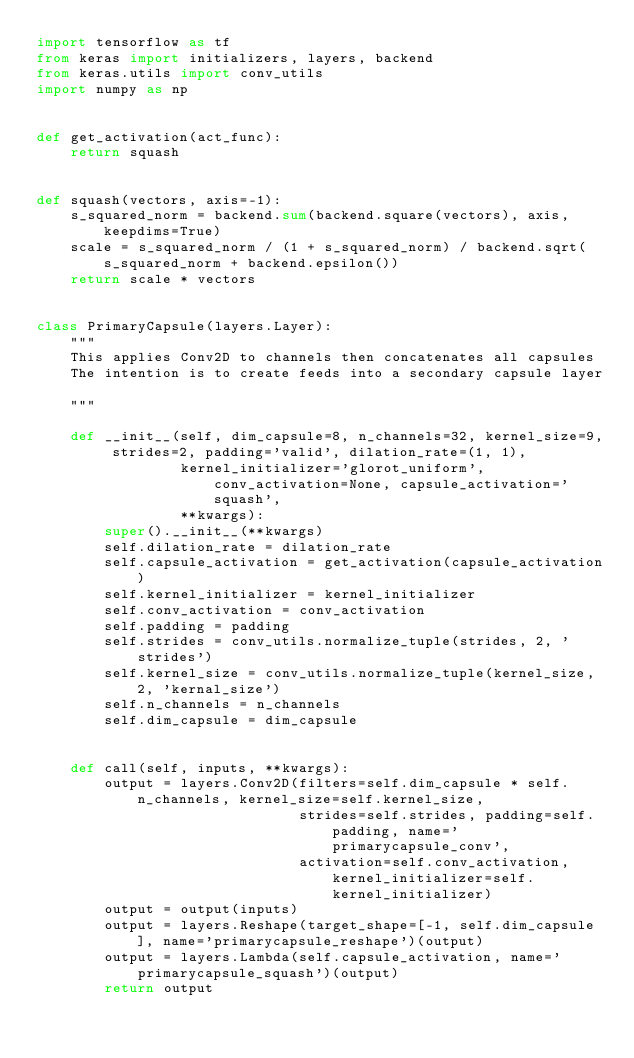Convert code to text. <code><loc_0><loc_0><loc_500><loc_500><_Python_>import tensorflow as tf
from keras import initializers, layers, backend
from keras.utils import conv_utils
import numpy as np


def get_activation(act_func):
    return squash


def squash(vectors, axis=-1):
    s_squared_norm = backend.sum(backend.square(vectors), axis, keepdims=True)
    scale = s_squared_norm / (1 + s_squared_norm) / backend.sqrt(s_squared_norm + backend.epsilon())
    return scale * vectors


class PrimaryCapsule(layers.Layer):
    """
    This applies Conv2D to channels then concatenates all capsules
    The intention is to create feeds into a secondary capsule layer

    """

    def __init__(self, dim_capsule=8, n_channels=32, kernel_size=9, strides=2, padding='valid', dilation_rate=(1, 1),
                 kernel_initializer='glorot_uniform', conv_activation=None, capsule_activation='squash',
                 **kwargs):
        super().__init__(**kwargs)
        self.dilation_rate = dilation_rate
        self.capsule_activation = get_activation(capsule_activation)
        self.kernel_initializer = kernel_initializer
        self.conv_activation = conv_activation
        self.padding = padding
        self.strides = conv_utils.normalize_tuple(strides, 2, 'strides')
        self.kernel_size = conv_utils.normalize_tuple(kernel_size, 2, 'kernal_size')
        self.n_channels = n_channels
        self.dim_capsule = dim_capsule


    def call(self, inputs, **kwargs):
        output = layers.Conv2D(filters=self.dim_capsule * self.n_channels, kernel_size=self.kernel_size,
                               strides=self.strides, padding=self.padding, name='primarycapsule_conv',
                               activation=self.conv_activation, kernel_initializer=self.kernel_initializer)
        output = output(inputs)
        output = layers.Reshape(target_shape=[-1, self.dim_capsule], name='primarycapsule_reshape')(output)
        output = layers.Lambda(self.capsule_activation, name='primarycapsule_squash')(output)
        return output
</code> 